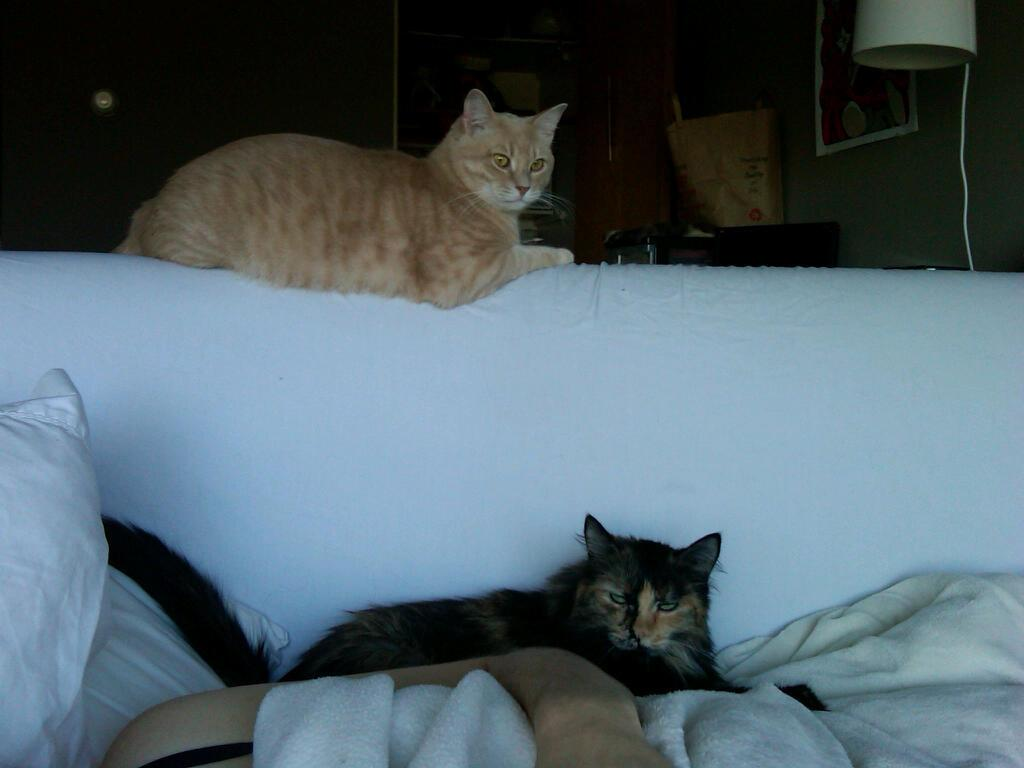What type of animals are sitting on the sofa in the image? There are cats sitting on a sofa in the image. What is located on the left side of the sofa? There are blankets and a pillow on the left side of the sofa. What is the color of the object in the image? There is a white object in the image. Where is the bag placed in the image? The bag is on a wooden desk in the image. What is hanging on the wall in the image? There is a frame on the wall in the image. What type of polish is being applied to the cats' fur in the image? There is no polish being applied to the cats' fur in the image; they are simply sitting on the sofa. What riddle is being solved by the cats in the image? There is no riddle being solved by the cats in the image; they are just sitting on the sofa. 